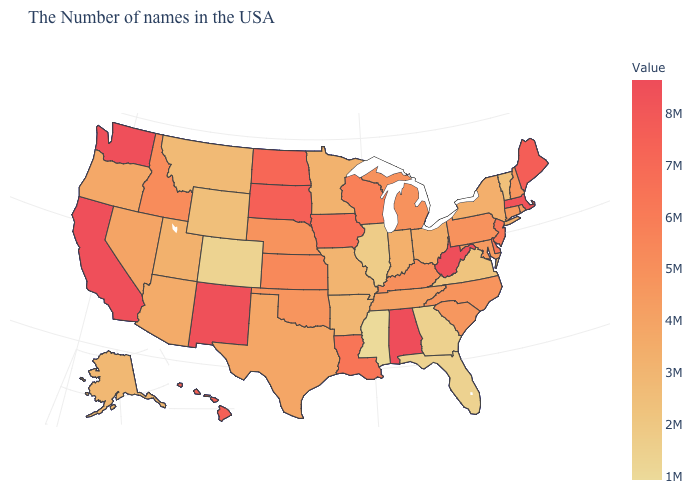Does Alabama have the highest value in the USA?
Short answer required. Yes. Does the map have missing data?
Be succinct. No. Does Mississippi have the lowest value in the USA?
Short answer required. Yes. Which states have the highest value in the USA?
Keep it brief. Alabama. Among the states that border Arizona , which have the lowest value?
Concise answer only. Colorado. Which states have the lowest value in the Northeast?
Be succinct. Vermont. Among the states that border Kansas , does Colorado have the highest value?
Write a very short answer. No. Does Louisiana have a higher value than Hawaii?
Give a very brief answer. No. 